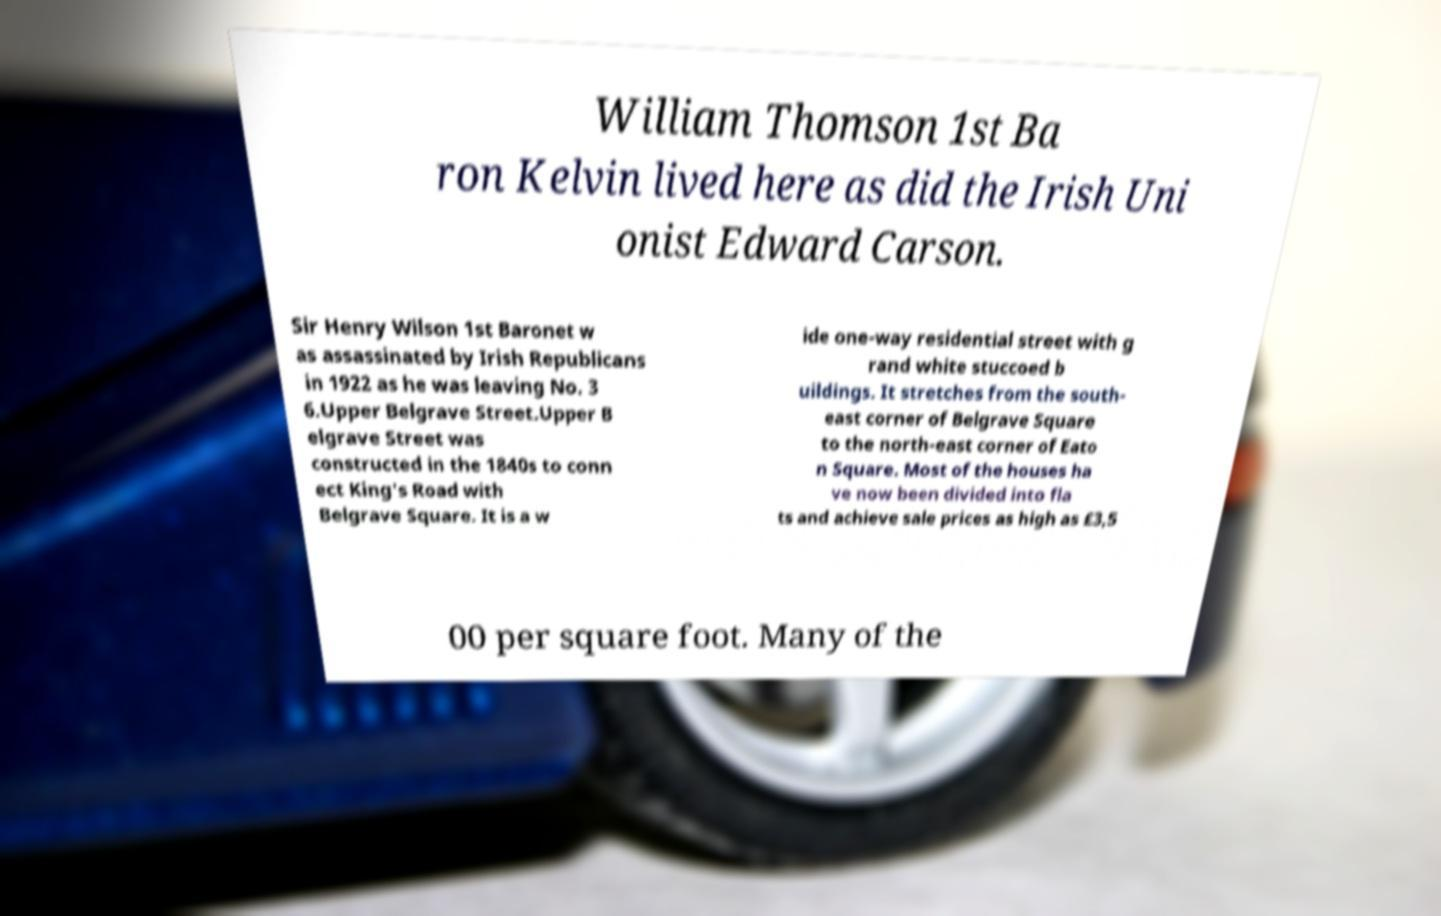Could you assist in decoding the text presented in this image and type it out clearly? William Thomson 1st Ba ron Kelvin lived here as did the Irish Uni onist Edward Carson. Sir Henry Wilson 1st Baronet w as assassinated by Irish Republicans in 1922 as he was leaving No. 3 6.Upper Belgrave Street.Upper B elgrave Street was constructed in the 1840s to conn ect King's Road with Belgrave Square. It is a w ide one-way residential street with g rand white stuccoed b uildings. It stretches from the south- east corner of Belgrave Square to the north-east corner of Eato n Square. Most of the houses ha ve now been divided into fla ts and achieve sale prices as high as £3,5 00 per square foot. Many of the 